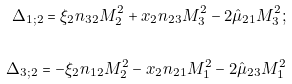<formula> <loc_0><loc_0><loc_500><loc_500>\Delta _ { 1 ; 2 } = \xi _ { 2 } n _ { 3 2 } M _ { 2 } ^ { 2 } + x _ { 2 } n _ { 2 3 } M _ { 3 } ^ { 2 } - 2 { \hat { \mu } } _ { 2 1 } M _ { 3 } ^ { 2 } ; \\ \\ \Delta _ { 3 ; 2 } = - \xi _ { 2 } n _ { 1 2 } M _ { 2 } ^ { 2 } - x _ { 2 } n _ { 2 1 } M _ { 1 } ^ { 2 } - 2 { \hat { \mu } } _ { 2 3 } M _ { 1 } ^ { 2 }</formula> 